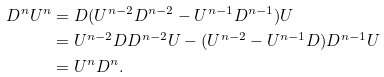Convert formula to latex. <formula><loc_0><loc_0><loc_500><loc_500>D ^ { n } U ^ { n } & = D ( U ^ { n - 2 } D ^ { n - 2 } - U ^ { n - 1 } D ^ { n - 1 } ) U \\ & = U ^ { n - 2 } D D ^ { n - 2 } U - ( U ^ { n - 2 } - U ^ { n - 1 } D ) D ^ { n - 1 } U \\ & = U ^ { n } D ^ { n } .</formula> 